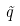<formula> <loc_0><loc_0><loc_500><loc_500>\tilde { q }</formula> 